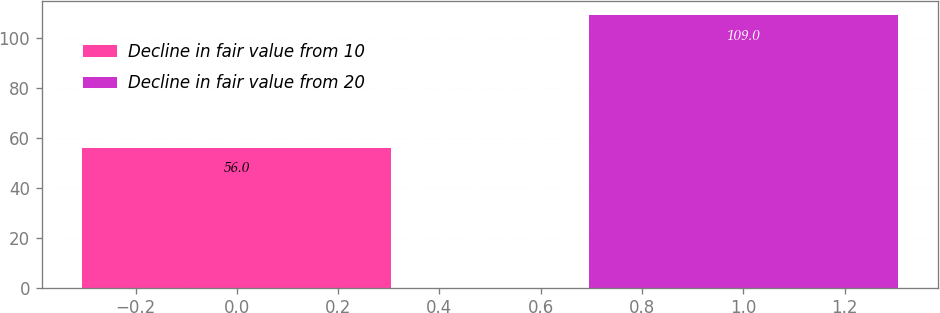Convert chart. <chart><loc_0><loc_0><loc_500><loc_500><bar_chart><fcel>Decline in fair value from 10<fcel>Decline in fair value from 20<nl><fcel>56<fcel>109<nl></chart> 